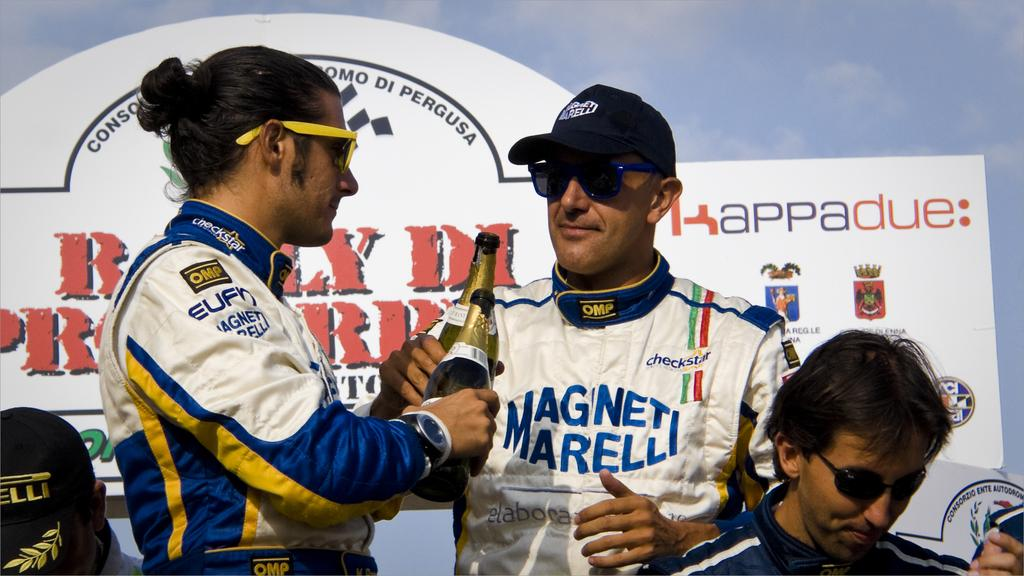<image>
Share a concise interpretation of the image provided. Two men toasting with bottles of champagne, one of whom is wearing a shirt with Magnet Marelli on it. 